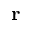Convert formula to latex. <formula><loc_0><loc_0><loc_500><loc_500>r</formula> 